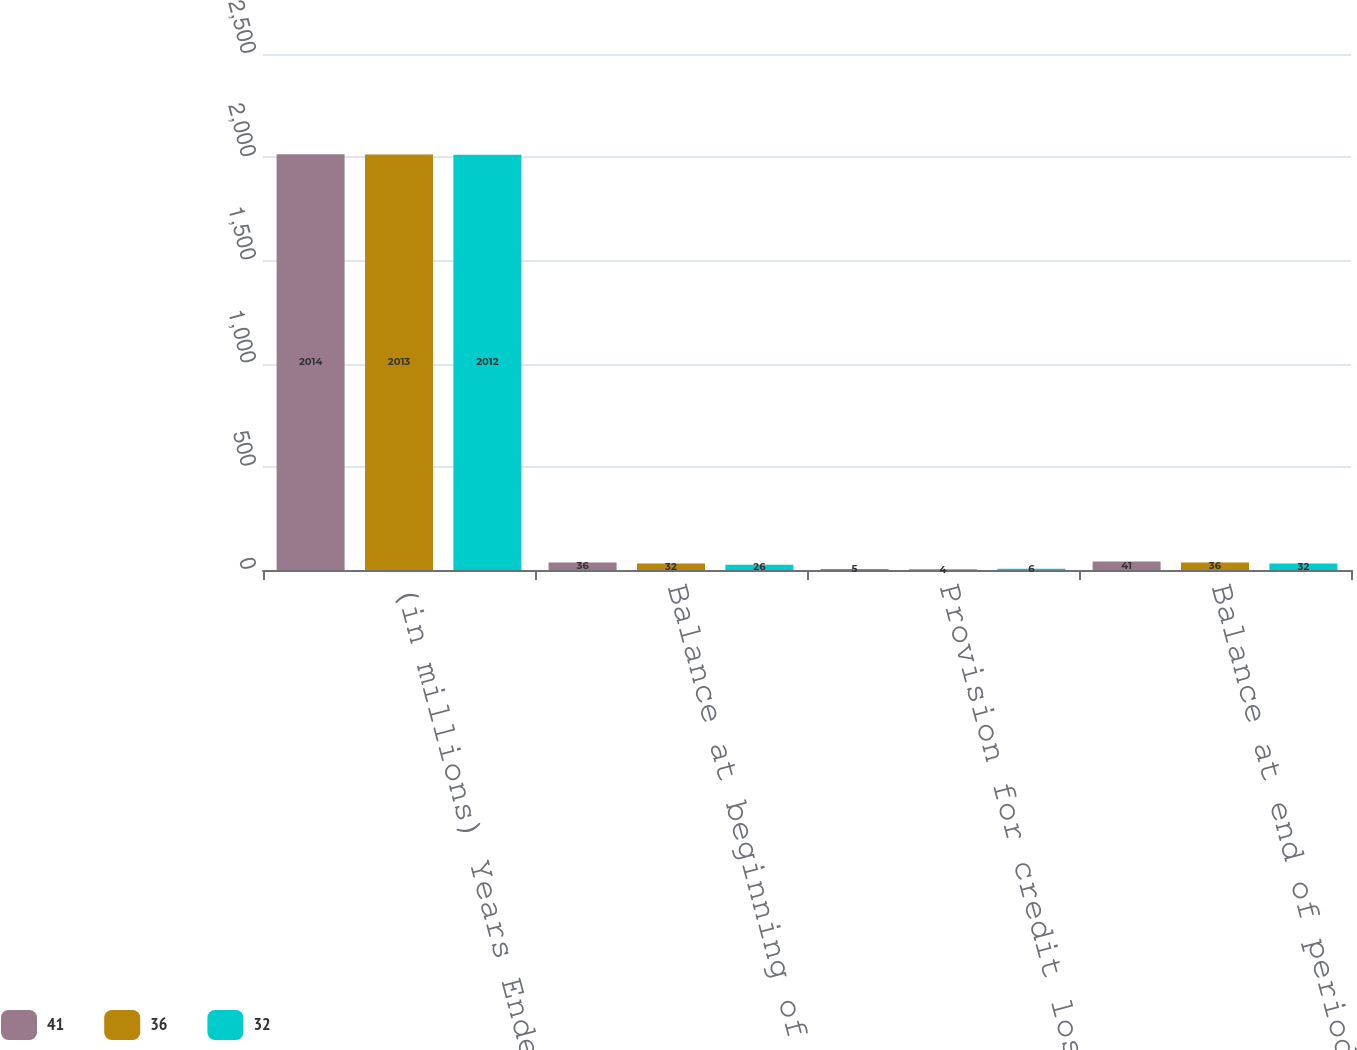Convert chart to OTSL. <chart><loc_0><loc_0><loc_500><loc_500><stacked_bar_chart><ecel><fcel>(in millions) Years Ended<fcel>Balance at beginning of period<fcel>Provision for credit losses on<fcel>Balance at end of period<nl><fcel>41<fcel>2014<fcel>36<fcel>5<fcel>41<nl><fcel>36<fcel>2013<fcel>32<fcel>4<fcel>36<nl><fcel>32<fcel>2012<fcel>26<fcel>6<fcel>32<nl></chart> 